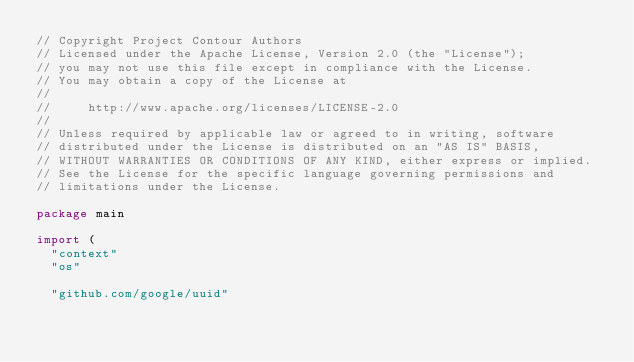Convert code to text. <code><loc_0><loc_0><loc_500><loc_500><_Go_>// Copyright Project Contour Authors
// Licensed under the Apache License, Version 2.0 (the "License");
// you may not use this file except in compliance with the License.
// You may obtain a copy of the License at
//
//     http://www.apache.org/licenses/LICENSE-2.0
//
// Unless required by applicable law or agreed to in writing, software
// distributed under the License is distributed on an "AS IS" BASIS,
// WITHOUT WARRANTIES OR CONDITIONS OF ANY KIND, either express or implied.
// See the License for the specific language governing permissions and
// limitations under the License.

package main

import (
	"context"
	"os"

	"github.com/google/uuid"</code> 